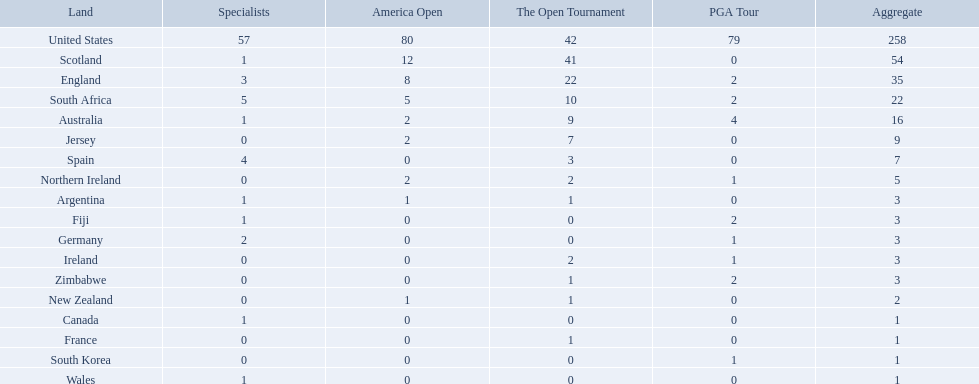Would you mind parsing the complete table? {'header': ['Land', 'Specialists', 'America Open', 'The Open Tournament', 'PGA Tour', 'Aggregate'], 'rows': [['United States', '57', '80', '42', '79', '258'], ['Scotland', '1', '12', '41', '0', '54'], ['England', '3', '8', '22', '2', '35'], ['South Africa', '5', '5', '10', '2', '22'], ['Australia', '1', '2', '9', '4', '16'], ['Jersey', '0', '2', '7', '0', '9'], ['Spain', '4', '0', '3', '0', '7'], ['Northern Ireland', '0', '2', '2', '1', '5'], ['Argentina', '1', '1', '1', '0', '3'], ['Fiji', '1', '0', '0', '2', '3'], ['Germany', '2', '0', '0', '1', '3'], ['Ireland', '0', '0', '2', '1', '3'], ['Zimbabwe', '0', '0', '1', '2', '3'], ['New Zealand', '0', '1', '1', '0', '2'], ['Canada', '1', '0', '0', '0', '1'], ['France', '0', '0', '1', '0', '1'], ['South Korea', '0', '0', '0', '1', '1'], ['Wales', '1', '0', '0', '0', '1']]} Which of the countries listed are african? South Africa, Zimbabwe. Which of those has the least championship winning golfers? Zimbabwe. What are all the countries? United States, Scotland, England, South Africa, Australia, Jersey, Spain, Northern Ireland, Argentina, Fiji, Germany, Ireland, Zimbabwe, New Zealand, Canada, France, South Korea, Wales. Which ones are located in africa? South Africa, Zimbabwe. Of those, which has the least champion golfers? Zimbabwe. 